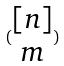<formula> <loc_0><loc_0><loc_500><loc_500>( \begin{matrix} [ n ] \\ m \end{matrix} )</formula> 